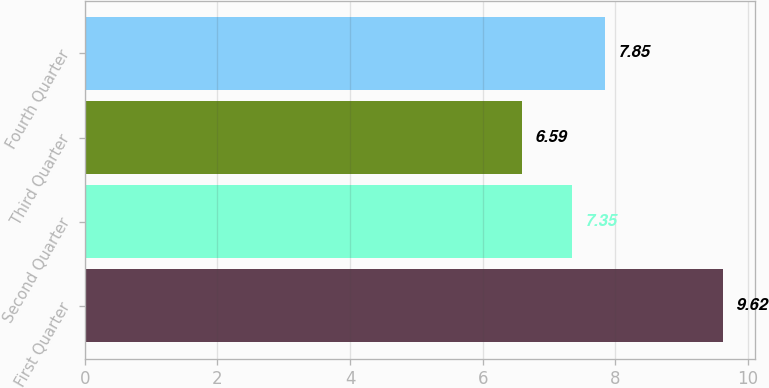<chart> <loc_0><loc_0><loc_500><loc_500><bar_chart><fcel>First Quarter<fcel>Second Quarter<fcel>Third Quarter<fcel>Fourth Quarter<nl><fcel>9.62<fcel>7.35<fcel>6.59<fcel>7.85<nl></chart> 